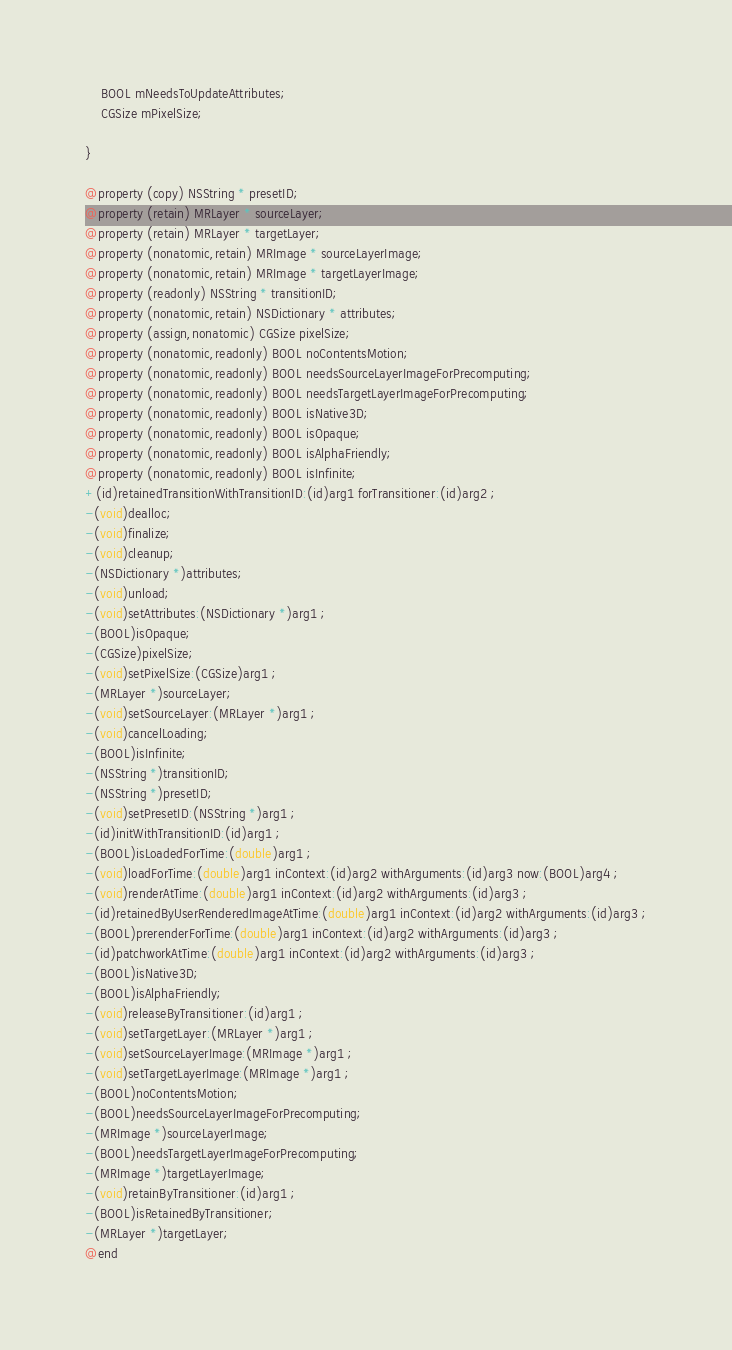<code> <loc_0><loc_0><loc_500><loc_500><_C_>	BOOL mNeedsToUpdateAttributes;
	CGSize mPixelSize;

}

@property (copy) NSString * presetID; 
@property (retain) MRLayer * sourceLayer; 
@property (retain) MRLayer * targetLayer; 
@property (nonatomic,retain) MRImage * sourceLayerImage; 
@property (nonatomic,retain) MRImage * targetLayerImage; 
@property (readonly) NSString * transitionID; 
@property (nonatomic,retain) NSDictionary * attributes; 
@property (assign,nonatomic) CGSize pixelSize; 
@property (nonatomic,readonly) BOOL noContentsMotion; 
@property (nonatomic,readonly) BOOL needsSourceLayerImageForPrecomputing; 
@property (nonatomic,readonly) BOOL needsTargetLayerImageForPrecomputing; 
@property (nonatomic,readonly) BOOL isNative3D; 
@property (nonatomic,readonly) BOOL isOpaque; 
@property (nonatomic,readonly) BOOL isAlphaFriendly; 
@property (nonatomic,readonly) BOOL isInfinite; 
+(id)retainedTransitionWithTransitionID:(id)arg1 forTransitioner:(id)arg2 ;
-(void)dealloc;
-(void)finalize;
-(void)cleanup;
-(NSDictionary *)attributes;
-(void)unload;
-(void)setAttributes:(NSDictionary *)arg1 ;
-(BOOL)isOpaque;
-(CGSize)pixelSize;
-(void)setPixelSize:(CGSize)arg1 ;
-(MRLayer *)sourceLayer;
-(void)setSourceLayer:(MRLayer *)arg1 ;
-(void)cancelLoading;
-(BOOL)isInfinite;
-(NSString *)transitionID;
-(NSString *)presetID;
-(void)setPresetID:(NSString *)arg1 ;
-(id)initWithTransitionID:(id)arg1 ;
-(BOOL)isLoadedForTime:(double)arg1 ;
-(void)loadForTime:(double)arg1 inContext:(id)arg2 withArguments:(id)arg3 now:(BOOL)arg4 ;
-(void)renderAtTime:(double)arg1 inContext:(id)arg2 withArguments:(id)arg3 ;
-(id)retainedByUserRenderedImageAtTime:(double)arg1 inContext:(id)arg2 withArguments:(id)arg3 ;
-(BOOL)prerenderForTime:(double)arg1 inContext:(id)arg2 withArguments:(id)arg3 ;
-(id)patchworkAtTime:(double)arg1 inContext:(id)arg2 withArguments:(id)arg3 ;
-(BOOL)isNative3D;
-(BOOL)isAlphaFriendly;
-(void)releaseByTransitioner:(id)arg1 ;
-(void)setTargetLayer:(MRLayer *)arg1 ;
-(void)setSourceLayerImage:(MRImage *)arg1 ;
-(void)setTargetLayerImage:(MRImage *)arg1 ;
-(BOOL)noContentsMotion;
-(BOOL)needsSourceLayerImageForPrecomputing;
-(MRImage *)sourceLayerImage;
-(BOOL)needsTargetLayerImageForPrecomputing;
-(MRImage *)targetLayerImage;
-(void)retainByTransitioner:(id)arg1 ;
-(BOOL)isRetainedByTransitioner;
-(MRLayer *)targetLayer;
@end

</code> 